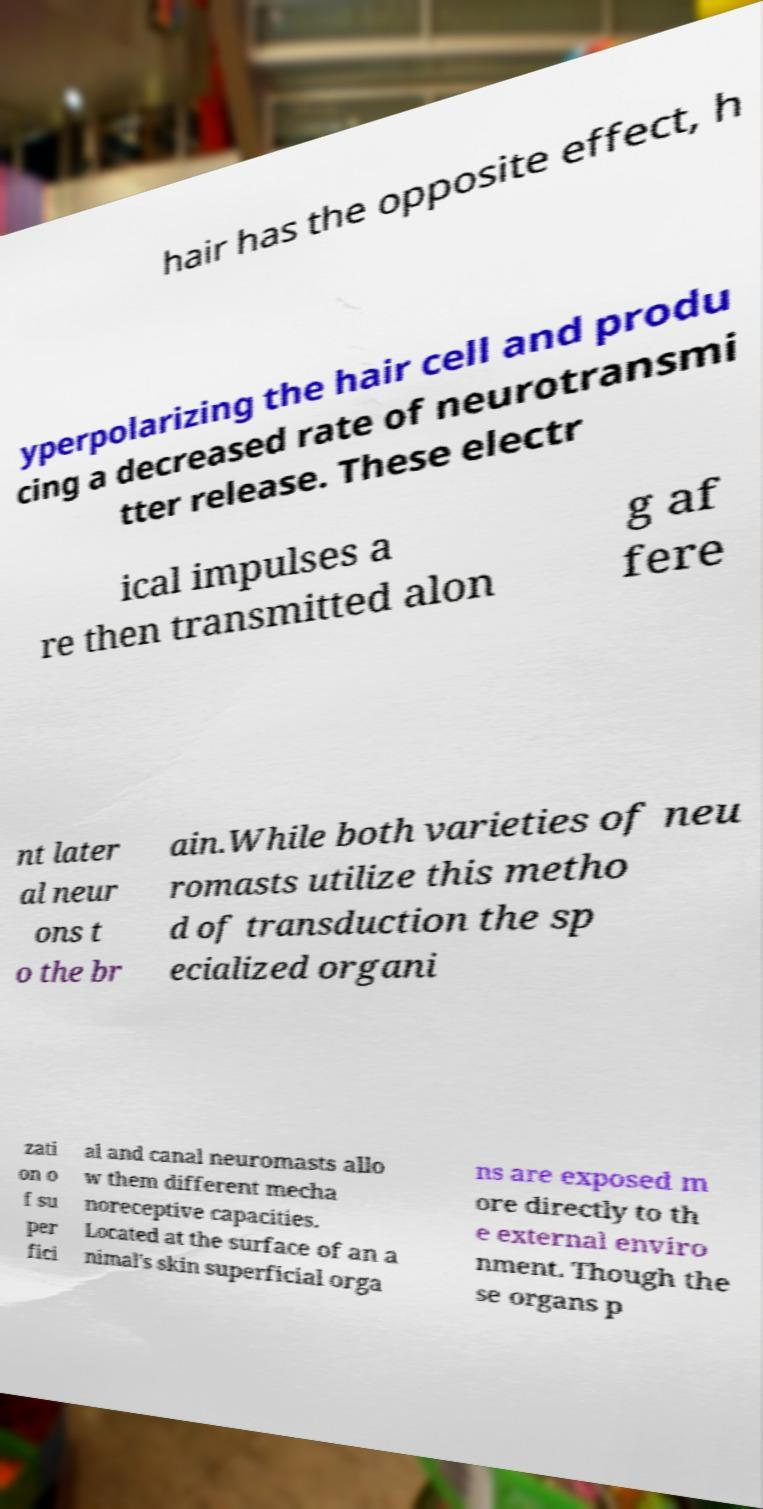For documentation purposes, I need the text within this image transcribed. Could you provide that? hair has the opposite effect, h yperpolarizing the hair cell and produ cing a decreased rate of neurotransmi tter release. These electr ical impulses a re then transmitted alon g af fere nt later al neur ons t o the br ain.While both varieties of neu romasts utilize this metho d of transduction the sp ecialized organi zati on o f su per fici al and canal neuromasts allo w them different mecha noreceptive capacities. Located at the surface of an a nimal's skin superficial orga ns are exposed m ore directly to th e external enviro nment. Though the se organs p 